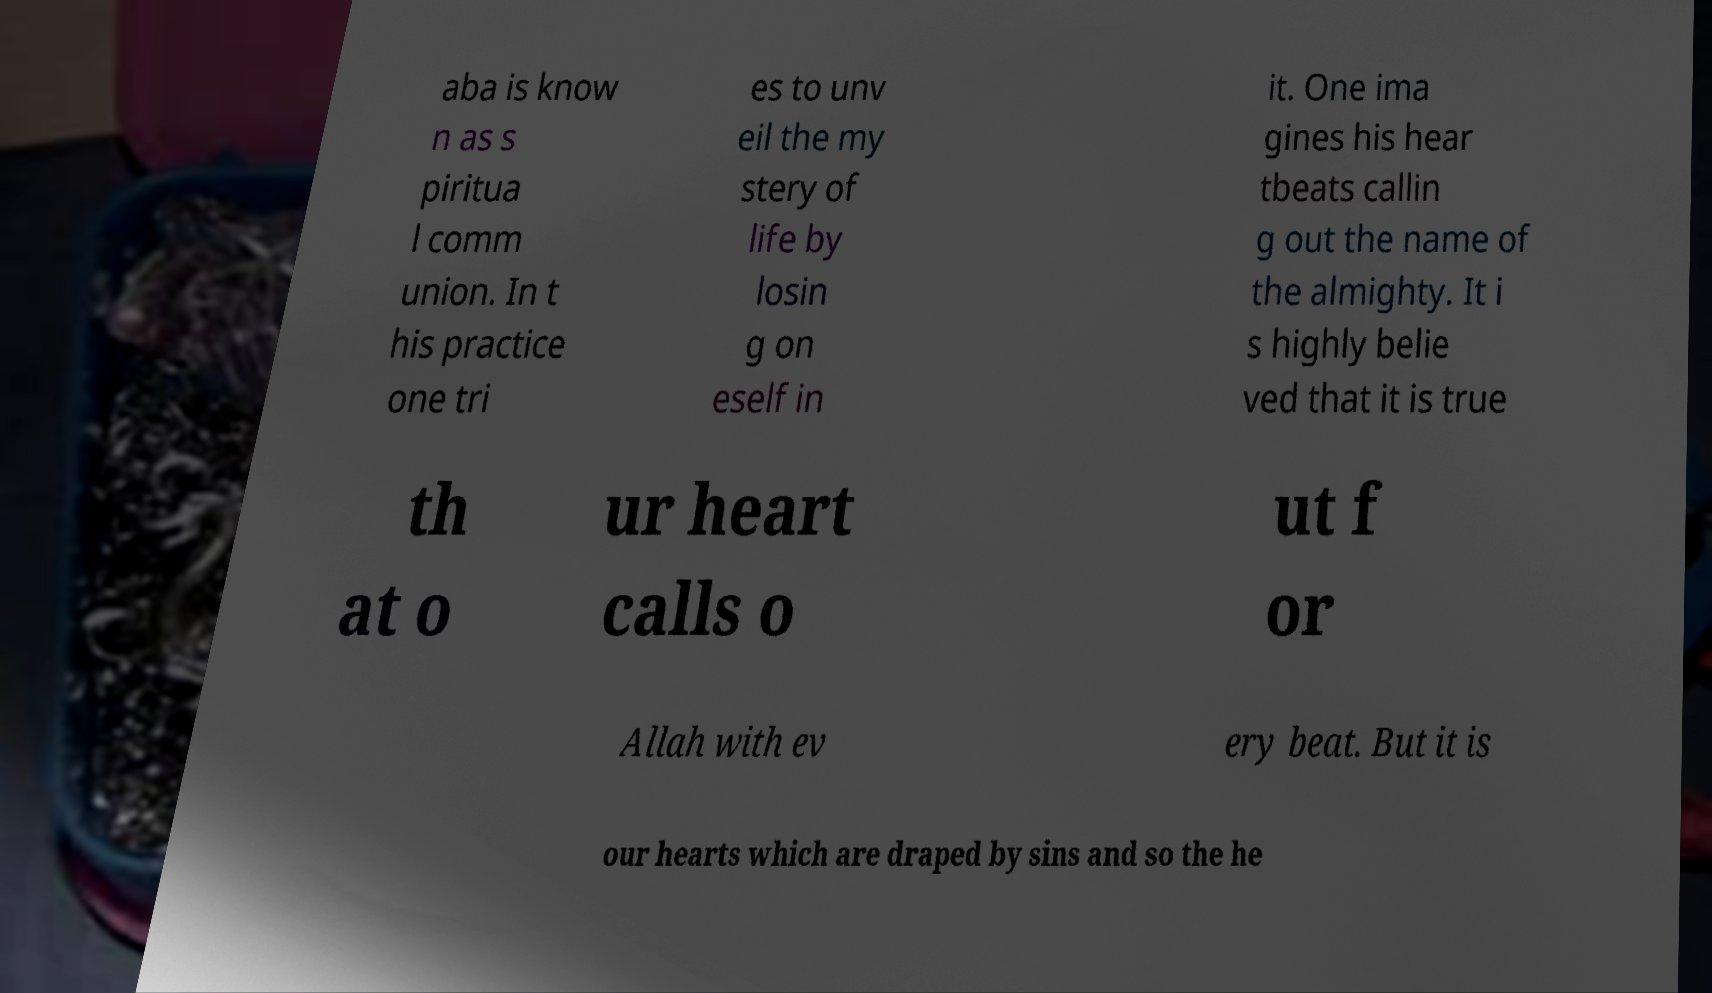There's text embedded in this image that I need extracted. Can you transcribe it verbatim? aba is know n as s piritua l comm union. In t his practice one tri es to unv eil the my stery of life by losin g on eself in it. One ima gines his hear tbeats callin g out the name of the almighty. It i s highly belie ved that it is true th at o ur heart calls o ut f or Allah with ev ery beat. But it is our hearts which are draped by sins and so the he 